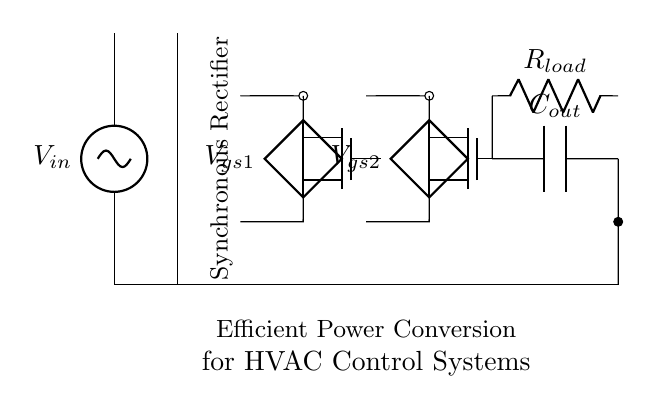What type of rectifier is shown in the circuit? The circuit diagram features a synchronous rectifier, indicated by the presence of controlled switches (MOSFETs) rather than diodes.
Answer: Synchronous rectifier What is the role of the MOSFETs in this circuit? The MOSFETs function as switching devices that control the flow of current, allowing for more efficient power conversion compared to traditional diodes.
Answer: Switches How many MOSFETs are used in this synchronous rectifier? The diagram shows two MOSFETs, labeled M1 and M2, used in the synchronous rectification process.
Answer: Two What component is used to smooth the output voltage? A capacitor, labeled C_out, is used to smooth the output voltage, providing stability to the electrical signal after rectification.
Answer: Capacitor What is the primary application of this circuit as stated in the diagram? The circuit is designed for efficient power conversion specifically for HVAC control systems, which manage heating, ventilation, and air conditioning.
Answer: HVAC control systems What is the load resistor labeled as in the circuit? The load resistor in the diagram is labeled R_load, which indicates the resistor's role in representing the load connected to the circuit.
Answer: R_load Why is this rectifier more efficient than traditional ones? This synchronous rectifier is more efficient because it minimizes voltage drop using MOSFETs compared to diodes, which leads to reduced power losses.
Answer: Reduced power losses 